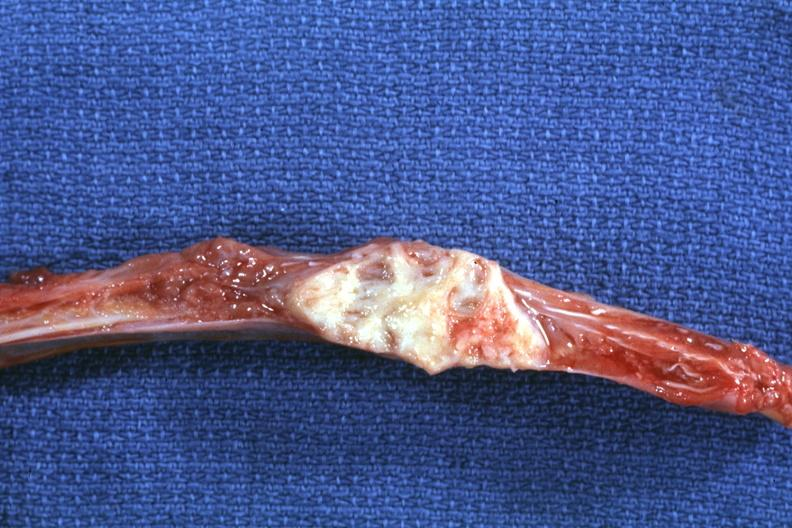s joints present?
Answer the question using a single word or phrase. Yes 